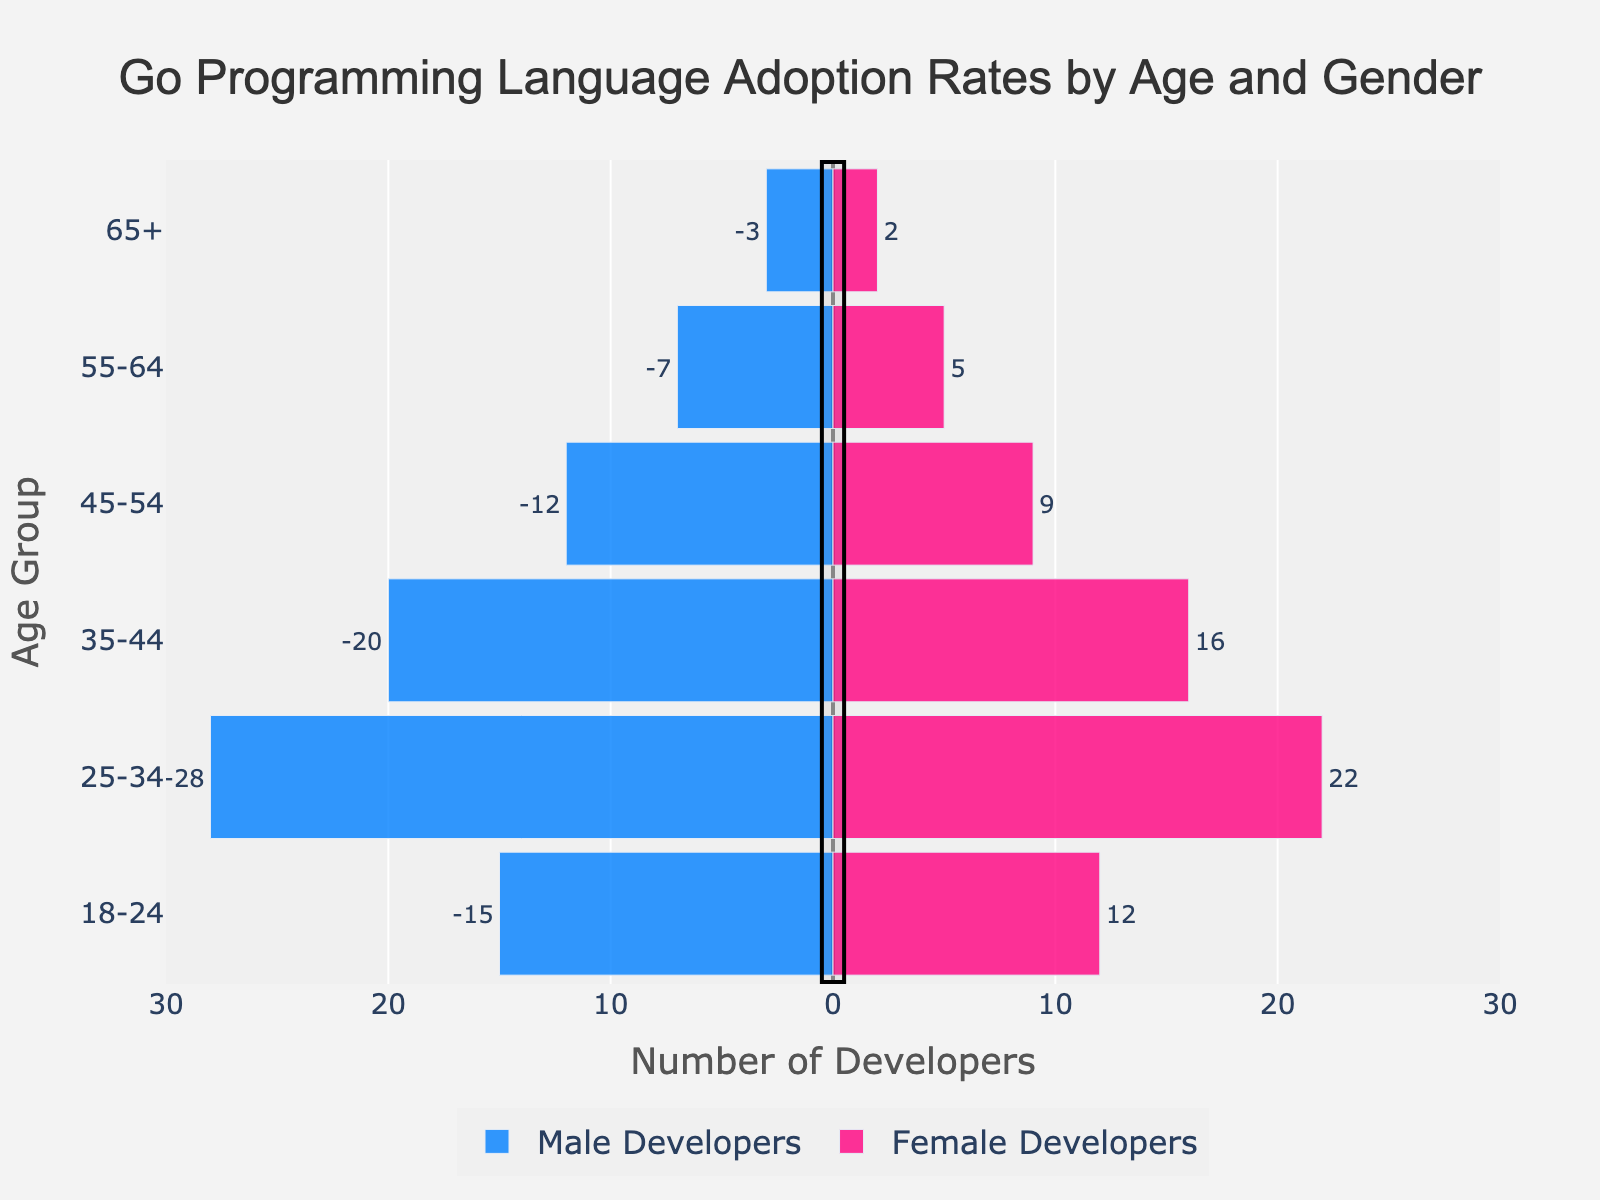What's the total number of developers aged 18-24? Add the number of male and female developers in the 18-24 age group: 15 (male) + 12 (female) = 27.
Answer: 27 Which age group has the highest number of male developers? Compare the number of male developers across all age groups. The 25-34 age group has the highest with 28 male developers.
Answer: 25-34 What's the ratio of male to female developers in the 35-44 age group? Divide the number of male developers (20) by the number of female developers (16) in the 35-44 age group: 20 / 16 = 1.25.
Answer: 1.25 Which gender has more developers in the 45-54 age group and by how many? Compare the number of male (12) and female (9) developers in the 45-54 age group: 12 - 9 = 3 more male developers.
Answer: Male by 3 What's the percentage of developers aged 65+ out of the total number of developers? Total developers = sum of all male and female developers: 15+12+28+22+20+16+12+9+7+5+3+2 = 151. Developers aged 65+ = 3 (male) + 2 (female) = 5. Calculate the percentage: (5 / 151) * 100 ≈ 3.31%.
Answer: 3.31% How many more developers are there in the 25-34 age group compared to the 55-64 age group? Total developers in 25-34 age group: 28 (male) + 22 (female) = 50. Total developers in 55-64 age group: 7 (male) + 5 (female) = 12. Difference: 50 - 12 = 38.
Answer: 38 What's the total number of female developers aged 25-64? Add the number of female developers in the 25-34, 35-44, 45-54, and 55-64 age groups: 22 + 16 + 9 + 5 = 52.
Answer: 52 Between which consecutive age groups is the drop in the number of male developers the largest? Calculate the difference for each consecutive group: 18-24 to 25-34: 28-15 = 13, 25-34 to 35-44: 28-20 = 8, 35-44 to 45-54: 20-12 = 8, 45-54 to 55-64: 12-7 = 5, 55-64 to 65+: 7-3 = 4. The largest drop is from 18-24 to 25-34 with a difference of 13.
Answer: 18-24 to 25-34 